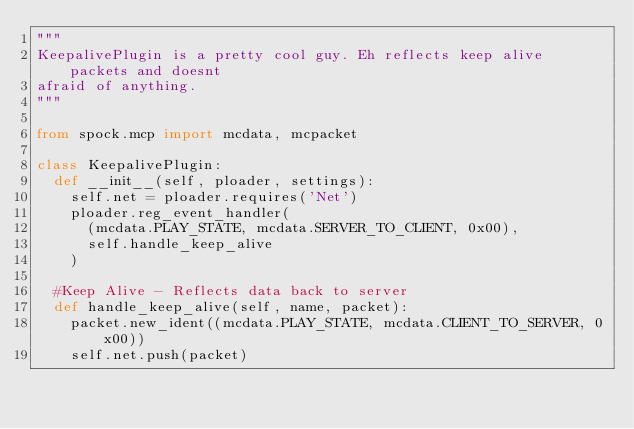<code> <loc_0><loc_0><loc_500><loc_500><_Python_>"""
KeepalivePlugin is a pretty cool guy. Eh reflects keep alive packets and doesnt
afraid of anything.
"""

from spock.mcp import mcdata, mcpacket

class KeepalivePlugin:
	def __init__(self, ploader, settings):
		self.net = ploader.requires('Net')
		ploader.reg_event_handler(
			(mcdata.PLAY_STATE, mcdata.SERVER_TO_CLIENT, 0x00),
			self.handle_keep_alive
		)

	#Keep Alive - Reflects data back to server
	def handle_keep_alive(self, name, packet):
		packet.new_ident((mcdata.PLAY_STATE, mcdata.CLIENT_TO_SERVER, 0x00))
		self.net.push(packet)
</code> 